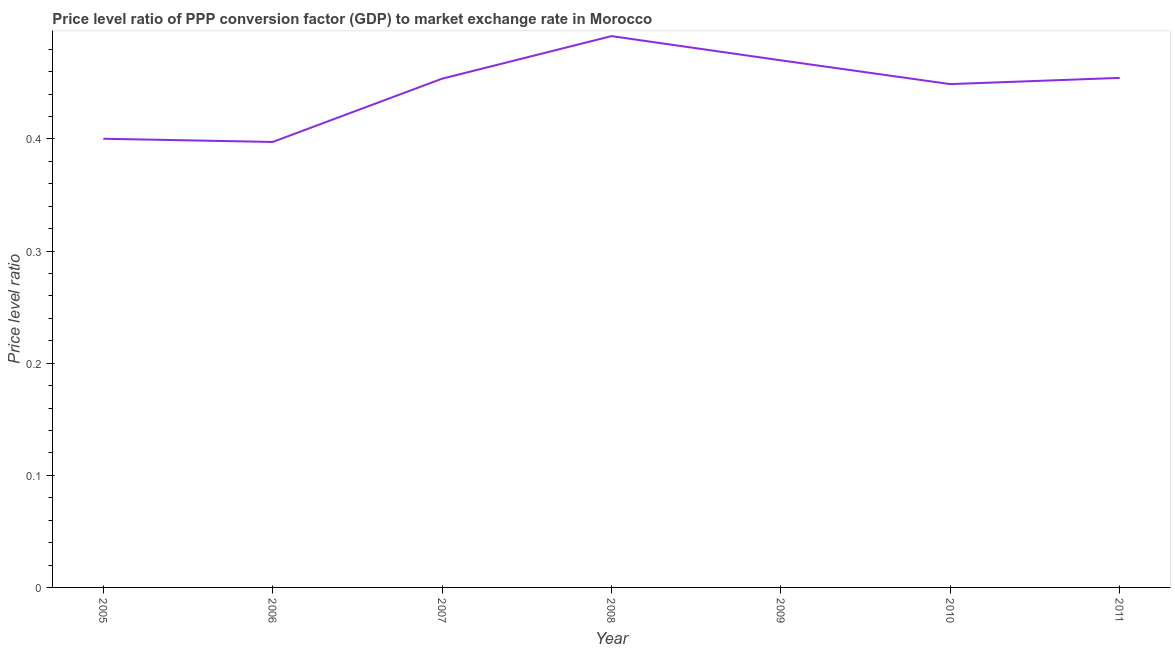What is the price level ratio in 2010?
Your answer should be very brief. 0.45. Across all years, what is the maximum price level ratio?
Make the answer very short. 0.49. Across all years, what is the minimum price level ratio?
Your answer should be compact. 0.4. In which year was the price level ratio maximum?
Provide a succinct answer. 2008. What is the sum of the price level ratio?
Your response must be concise. 3.12. What is the difference between the price level ratio in 2007 and 2009?
Keep it short and to the point. -0.02. What is the average price level ratio per year?
Provide a succinct answer. 0.45. What is the median price level ratio?
Offer a terse response. 0.45. What is the ratio of the price level ratio in 2007 to that in 2011?
Your answer should be compact. 1. Is the price level ratio in 2008 less than that in 2011?
Give a very brief answer. No. Is the difference between the price level ratio in 2006 and 2008 greater than the difference between any two years?
Make the answer very short. Yes. What is the difference between the highest and the second highest price level ratio?
Give a very brief answer. 0.02. What is the difference between the highest and the lowest price level ratio?
Provide a short and direct response. 0.09. How many lines are there?
Keep it short and to the point. 1. Does the graph contain grids?
Offer a very short reply. No. What is the title of the graph?
Ensure brevity in your answer.  Price level ratio of PPP conversion factor (GDP) to market exchange rate in Morocco. What is the label or title of the Y-axis?
Offer a very short reply. Price level ratio. What is the Price level ratio in 2005?
Offer a terse response. 0.4. What is the Price level ratio of 2006?
Your response must be concise. 0.4. What is the Price level ratio of 2007?
Provide a succinct answer. 0.45. What is the Price level ratio in 2008?
Offer a terse response. 0.49. What is the Price level ratio of 2009?
Your answer should be compact. 0.47. What is the Price level ratio in 2010?
Make the answer very short. 0.45. What is the Price level ratio of 2011?
Ensure brevity in your answer.  0.45. What is the difference between the Price level ratio in 2005 and 2006?
Give a very brief answer. 0. What is the difference between the Price level ratio in 2005 and 2007?
Give a very brief answer. -0.05. What is the difference between the Price level ratio in 2005 and 2008?
Ensure brevity in your answer.  -0.09. What is the difference between the Price level ratio in 2005 and 2009?
Offer a very short reply. -0.07. What is the difference between the Price level ratio in 2005 and 2010?
Offer a very short reply. -0.05. What is the difference between the Price level ratio in 2005 and 2011?
Your response must be concise. -0.05. What is the difference between the Price level ratio in 2006 and 2007?
Offer a terse response. -0.06. What is the difference between the Price level ratio in 2006 and 2008?
Provide a succinct answer. -0.09. What is the difference between the Price level ratio in 2006 and 2009?
Give a very brief answer. -0.07. What is the difference between the Price level ratio in 2006 and 2010?
Offer a terse response. -0.05. What is the difference between the Price level ratio in 2006 and 2011?
Provide a short and direct response. -0.06. What is the difference between the Price level ratio in 2007 and 2008?
Offer a very short reply. -0.04. What is the difference between the Price level ratio in 2007 and 2009?
Provide a short and direct response. -0.02. What is the difference between the Price level ratio in 2007 and 2010?
Your response must be concise. 0. What is the difference between the Price level ratio in 2007 and 2011?
Your answer should be compact. -0. What is the difference between the Price level ratio in 2008 and 2009?
Provide a short and direct response. 0.02. What is the difference between the Price level ratio in 2008 and 2010?
Give a very brief answer. 0.04. What is the difference between the Price level ratio in 2008 and 2011?
Your answer should be very brief. 0.04. What is the difference between the Price level ratio in 2009 and 2010?
Provide a succinct answer. 0.02. What is the difference between the Price level ratio in 2009 and 2011?
Keep it short and to the point. 0.02. What is the difference between the Price level ratio in 2010 and 2011?
Ensure brevity in your answer.  -0.01. What is the ratio of the Price level ratio in 2005 to that in 2007?
Provide a short and direct response. 0.88. What is the ratio of the Price level ratio in 2005 to that in 2008?
Your answer should be compact. 0.81. What is the ratio of the Price level ratio in 2005 to that in 2009?
Offer a terse response. 0.85. What is the ratio of the Price level ratio in 2005 to that in 2010?
Give a very brief answer. 0.89. What is the ratio of the Price level ratio in 2005 to that in 2011?
Offer a very short reply. 0.88. What is the ratio of the Price level ratio in 2006 to that in 2007?
Ensure brevity in your answer.  0.88. What is the ratio of the Price level ratio in 2006 to that in 2008?
Keep it short and to the point. 0.81. What is the ratio of the Price level ratio in 2006 to that in 2009?
Make the answer very short. 0.84. What is the ratio of the Price level ratio in 2006 to that in 2010?
Provide a short and direct response. 0.89. What is the ratio of the Price level ratio in 2006 to that in 2011?
Your answer should be very brief. 0.87. What is the ratio of the Price level ratio in 2007 to that in 2008?
Your answer should be very brief. 0.92. What is the ratio of the Price level ratio in 2007 to that in 2009?
Keep it short and to the point. 0.96. What is the ratio of the Price level ratio in 2008 to that in 2009?
Make the answer very short. 1.05. What is the ratio of the Price level ratio in 2008 to that in 2010?
Your answer should be very brief. 1.09. What is the ratio of the Price level ratio in 2008 to that in 2011?
Give a very brief answer. 1.08. What is the ratio of the Price level ratio in 2009 to that in 2010?
Give a very brief answer. 1.05. What is the ratio of the Price level ratio in 2009 to that in 2011?
Your answer should be compact. 1.03. 